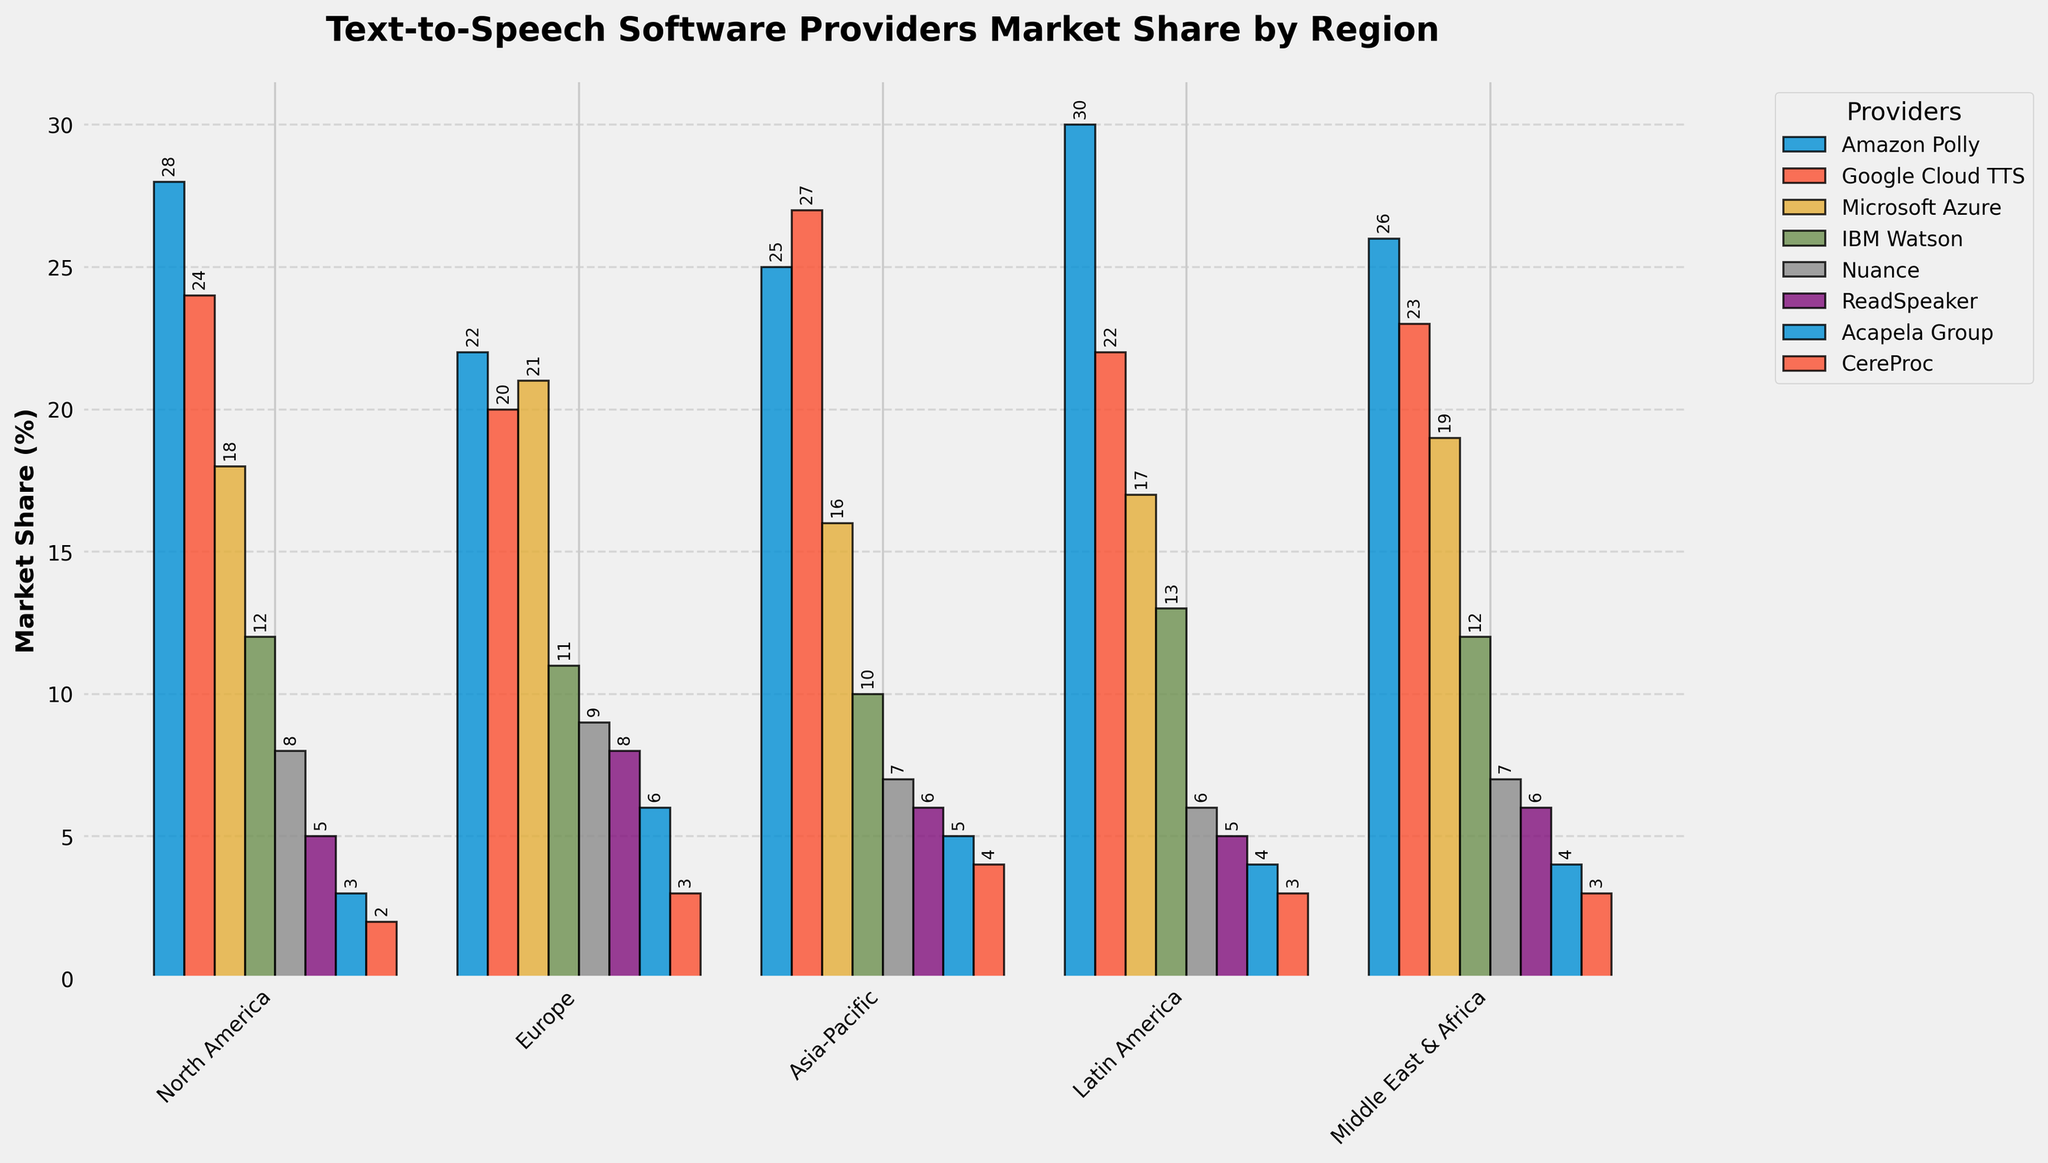What is the market share of Amazon Polly in North America? The market share of Amazon Polly in North America can be directly read from the figure. Look at the bar height for Amazon Polly in the North America region.
Answer: 28% Which provider has the largest market share in Europe? To find which provider has the largest market share, compare the heights of the bars for each provider in the Europe region. The highest bar corresponds to Microsoft Azure.
Answer: Microsoft Azure How does the market share of Google Cloud TTS in Asia-Pacific compare to Microsoft Azure in the same region? Compare the heights of the bars representing Google Cloud TTS and Microsoft Azure in the Asia-Pacific region. Google Cloud TTS has a higher bar than Microsoft Azure.
Answer: Google Cloud TTS has a higher market share What is the total market share of Nuance across all regions? Sum the market share values of Nuance in all regions: North America (8) + Europe (9) + Asia-Pacific (7) + Latin America (6) + Middle East & Africa (7).
Answer: 37% In which region does ReadSpeaker have the least market share, and what is that value? Look for the shortest bar representing ReadSpeaker across all regions. ReadSpeaker has the least market share in North America with a value of 5%.
Answer: North America, 5% What is the average market share of IBM Watson across all regions? Add the market share values of IBM Watson in all regions and divide by the number of regions: (12 + 11 + 10 + 13 + 12)/5.
Answer: 11.6% How does the total market share of Acapela Group in North America and Europe compare? Add the market share values of Acapela Group in these two regions: North America (3) + Europe (6). The total is 9.
Answer: 9% Which provider has the most consistent market share in all regions? The most consistent market share would have bars of similar height across all regions. Google Cloud TTS appears to have relatively similar market share values without significant fluctuation.
Answer: Google Cloud TTS Considering CereProc, which region has the highest market share, and what is the value? Identify the tallest bar for CereProc across all regions. Asia-Pacific has the highest market share for CereProc with a value of 4%.
Answer: Asia-Pacific, 4% Is the market share of Amazon Polly greater in Latin America or Middle East & Africa, and by how much? Compare the heights of the bars for Amazon Polly in both regions. Latin America has a market share of 30%, and Middle East & Africa has 26%. The difference is 30% - 26%.
Answer: Latin America by 4% 